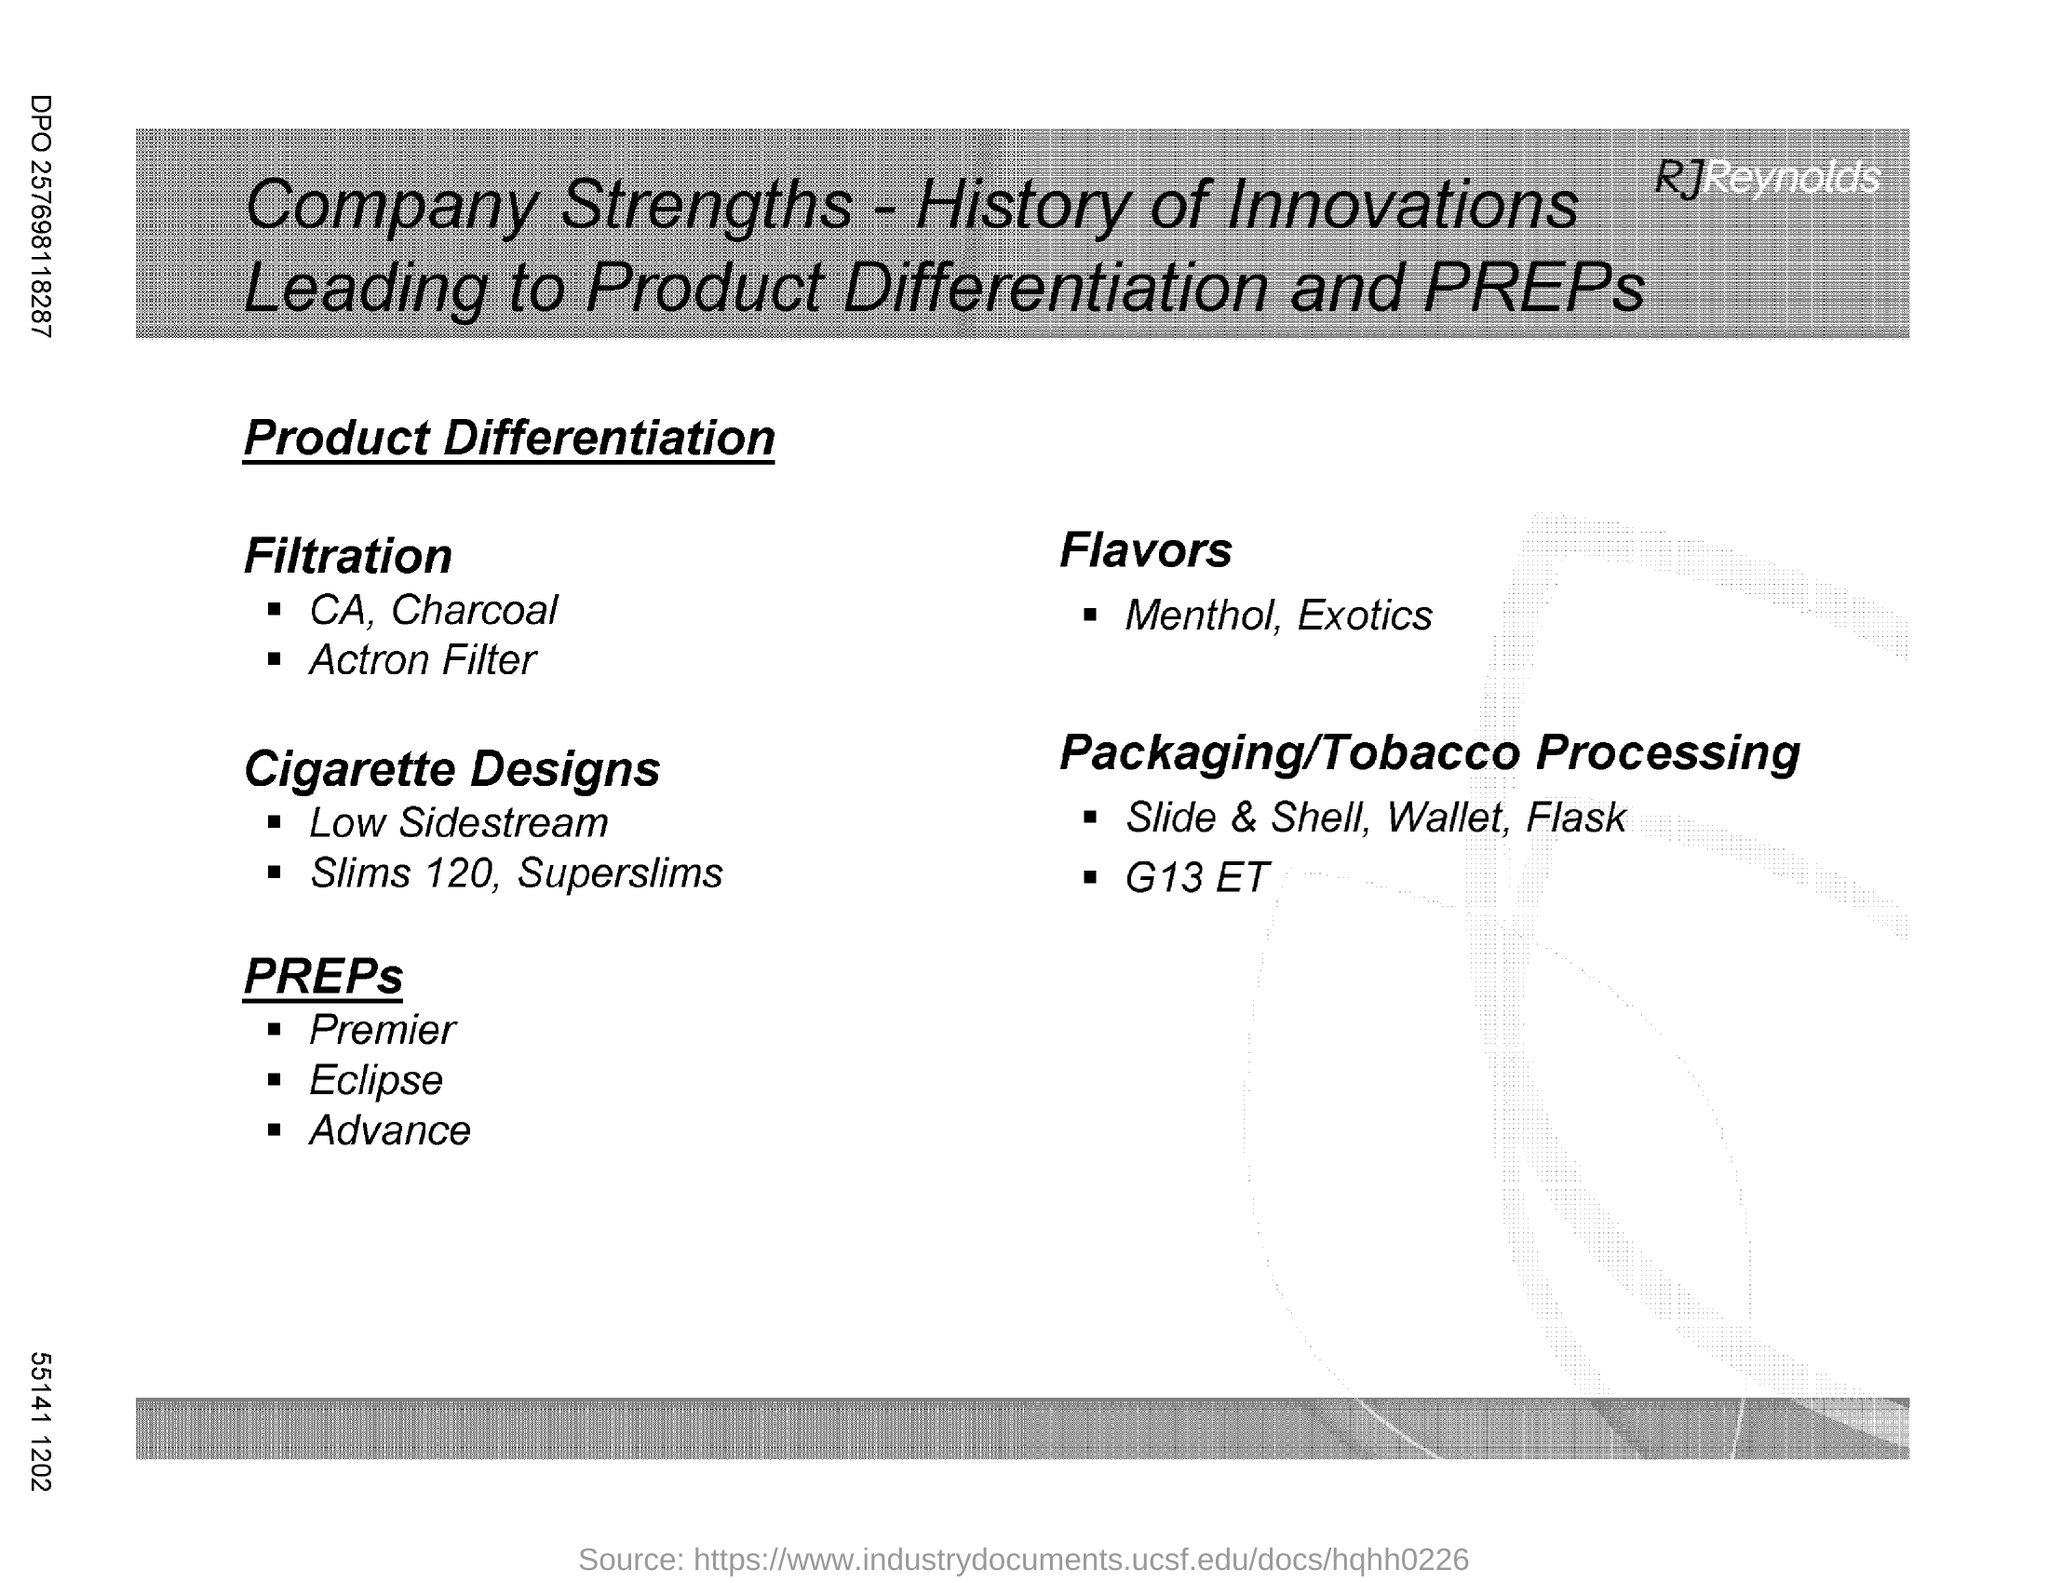What are the flavors mentioned here?
Offer a terse response. Menthol, Exotics. 